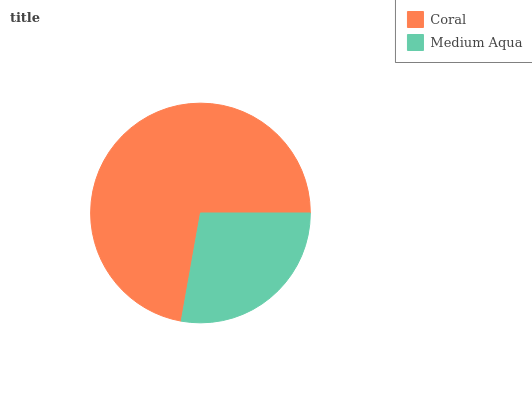Is Medium Aqua the minimum?
Answer yes or no. Yes. Is Coral the maximum?
Answer yes or no. Yes. Is Medium Aqua the maximum?
Answer yes or no. No. Is Coral greater than Medium Aqua?
Answer yes or no. Yes. Is Medium Aqua less than Coral?
Answer yes or no. Yes. Is Medium Aqua greater than Coral?
Answer yes or no. No. Is Coral less than Medium Aqua?
Answer yes or no. No. Is Coral the high median?
Answer yes or no. Yes. Is Medium Aqua the low median?
Answer yes or no. Yes. Is Medium Aqua the high median?
Answer yes or no. No. Is Coral the low median?
Answer yes or no. No. 